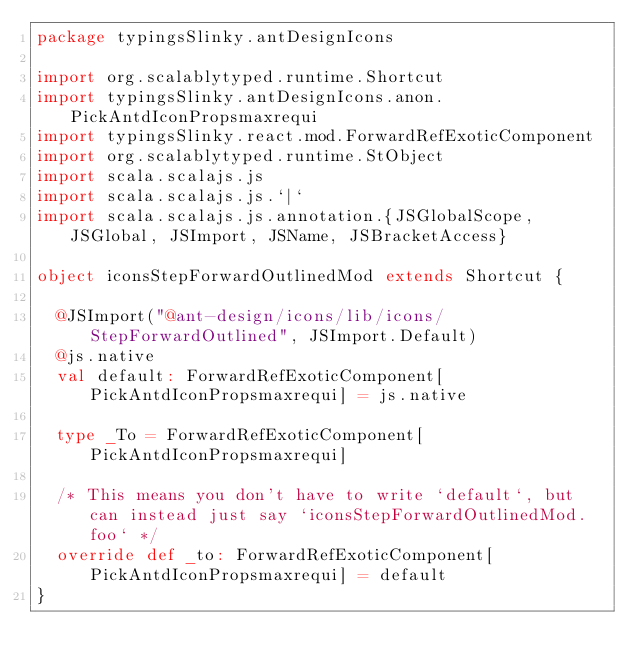Convert code to text. <code><loc_0><loc_0><loc_500><loc_500><_Scala_>package typingsSlinky.antDesignIcons

import org.scalablytyped.runtime.Shortcut
import typingsSlinky.antDesignIcons.anon.PickAntdIconPropsmaxrequi
import typingsSlinky.react.mod.ForwardRefExoticComponent
import org.scalablytyped.runtime.StObject
import scala.scalajs.js
import scala.scalajs.js.`|`
import scala.scalajs.js.annotation.{JSGlobalScope, JSGlobal, JSImport, JSName, JSBracketAccess}

object iconsStepForwardOutlinedMod extends Shortcut {
  
  @JSImport("@ant-design/icons/lib/icons/StepForwardOutlined", JSImport.Default)
  @js.native
  val default: ForwardRefExoticComponent[PickAntdIconPropsmaxrequi] = js.native
  
  type _To = ForwardRefExoticComponent[PickAntdIconPropsmaxrequi]
  
  /* This means you don't have to write `default`, but can instead just say `iconsStepForwardOutlinedMod.foo` */
  override def _to: ForwardRefExoticComponent[PickAntdIconPropsmaxrequi] = default
}
</code> 